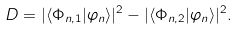<formula> <loc_0><loc_0><loc_500><loc_500>\ D = | \langle { \Phi } _ { n , 1 } | \varphi _ { n } \rangle | ^ { 2 } - | \langle { \Phi } _ { n , 2 } | \varphi _ { n } \rangle | ^ { 2 } .</formula> 